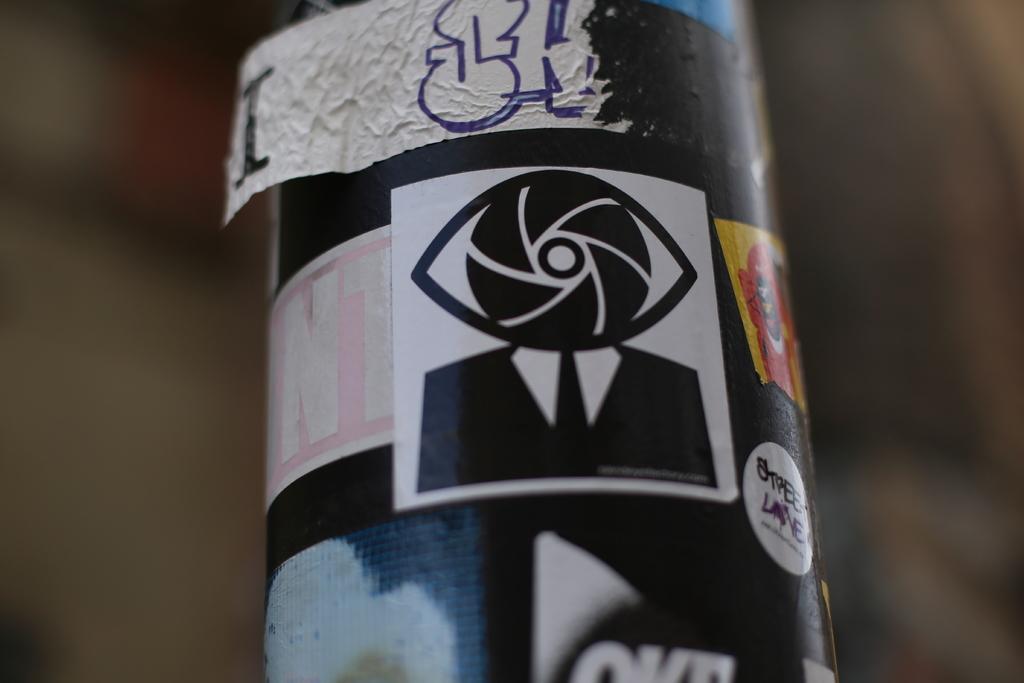Can you describe this image briefly? In this picture, there is a pole. On the pole, there are some stickers. 